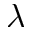<formula> <loc_0><loc_0><loc_500><loc_500>\lambda</formula> 